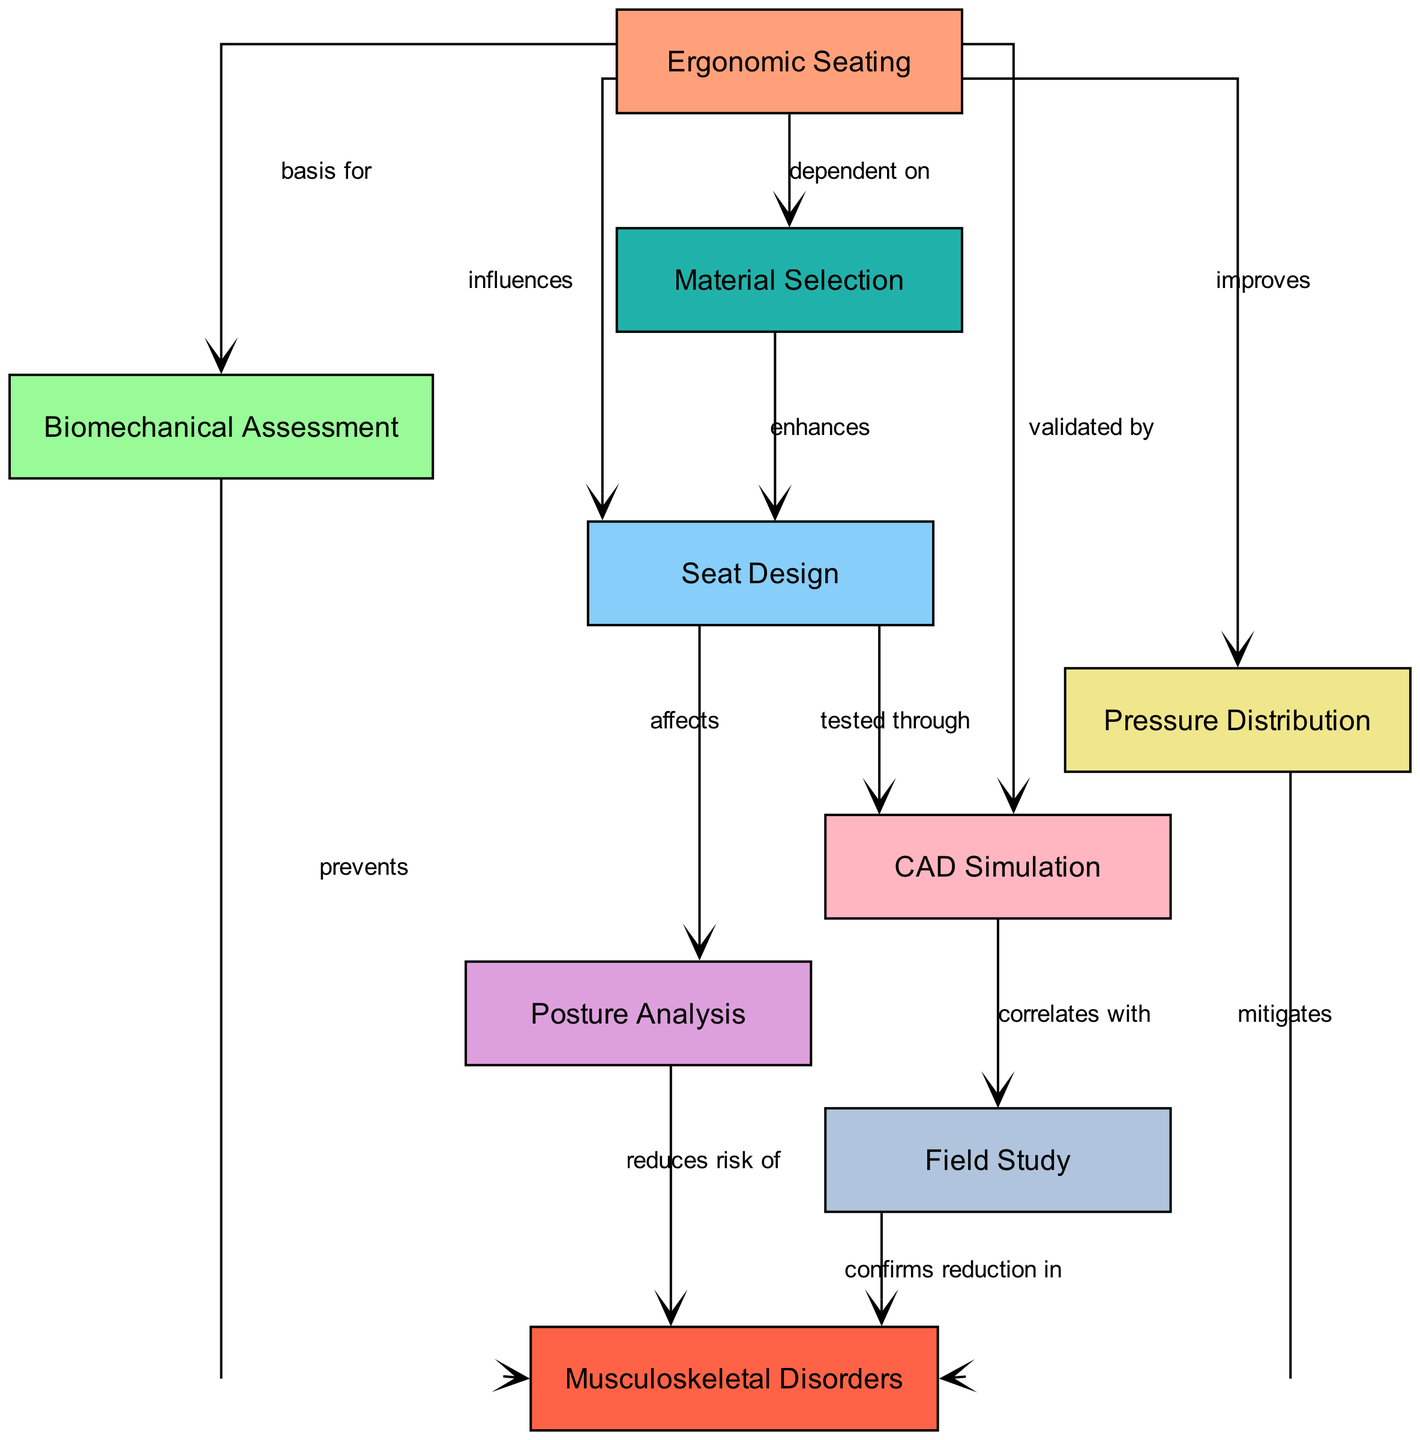What is the total number of nodes in the diagram? The diagram contains the following nodes: Ergonomic Seating, Biomechanical Assessment, Musculoskeletal Disorders, Seat Design, Posture Analysis, Pressure Distribution, Material Selection, CAD Simulation, and Field Study. Counting these, there are 9 nodes total.
Answer: 9 What relationship does "Seat Design" have with "Posture Analysis"? The diagram indicates that "Seat Design" affects "Posture Analysis". This means that the design of the seat plays a role in how posture is analyzed.
Answer: affects How does "Ergonomic Seating" relate to "Musculoskeletal Disorders"? According to the diagram, "Ergonomic Seating" is the basis for "Biomechanical Assessment", which helps to prevent "Musculoskeletal Disorders". This implies there is an indirect relation where ergonomic seating is foundational to preventing such disorders.
Answer: prevents What does "Material Selection" enhance? The diagram specifies that "Material Selection" enhances "Seat Design". This indicates that the type of materials chosen for seats will improve their design.
Answer: Seat Design Which node validates "CAD Simulation"? The diagram shows that "Ergonomic Seating" validates "CAD Simulation". This indicates that the effectiveness of the CAD simulations is confirmed by ergonomic seating principles.
Answer: Ergonomic Seating What confirms the reduction in "Musculoskeletal Disorders"? The diagram states that the "Field Study" confirms the reduction in "Musculoskeletal Disorders". This means that findings from field studies have shown a decrease in these disorders.
Answer: Field Study What aspect does "Pressure Distribution" mitigate? The diagram indicates that "Pressure Distribution" mitigates "Musculoskeletal Disorders". Therefore, it helps to lessen the occurrence or severity of these disorders.
Answer: Musculoskeletal Disorders How does "CAD Simulation" correlate with "Field Study"? The diagram demonstrates that "CAD Simulation" correlates with "Field Study". This implies that the results observed in field studies align with the outcomes predicted by CAD simulations.
Answer: correlates with What is dependent on "Ergonomic Seating"? According to the diagram, "Material Selection" is dependent on "Ergonomic Seating". This indicates that the selection of materials for seats is based on ergonomic principles.
Answer: Material Selection 